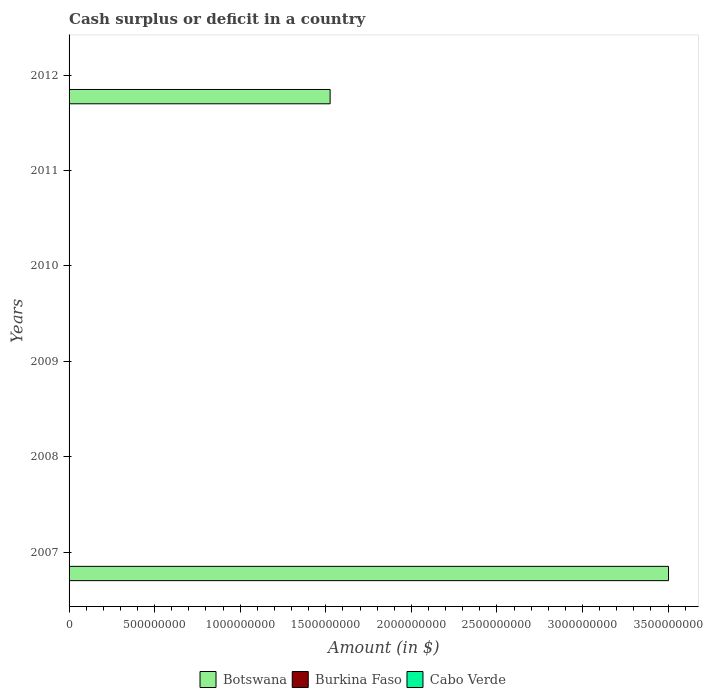How many different coloured bars are there?
Make the answer very short. 1. Are the number of bars on each tick of the Y-axis equal?
Offer a terse response. No. How many bars are there on the 4th tick from the top?
Your response must be concise. 0. Across all years, what is the maximum amount of cash surplus or deficit in Botswana?
Ensure brevity in your answer.  3.50e+09. In which year was the amount of cash surplus or deficit in Botswana maximum?
Your answer should be very brief. 2007. What is the total amount of cash surplus or deficit in Botswana in the graph?
Your answer should be compact. 5.03e+09. What is the difference between the amount of cash surplus or deficit in Cabo Verde in 2008 and the amount of cash surplus or deficit in Burkina Faso in 2007?
Your answer should be compact. 0. What is the average amount of cash surplus or deficit in Cabo Verde per year?
Provide a succinct answer. 0. In how many years, is the amount of cash surplus or deficit in Burkina Faso greater than 3000000000 $?
Provide a succinct answer. 0. What is the difference between the highest and the lowest amount of cash surplus or deficit in Botswana?
Offer a very short reply. 3.50e+09. In how many years, is the amount of cash surplus or deficit in Botswana greater than the average amount of cash surplus or deficit in Botswana taken over all years?
Give a very brief answer. 2. Is it the case that in every year, the sum of the amount of cash surplus or deficit in Botswana and amount of cash surplus or deficit in Cabo Verde is greater than the amount of cash surplus or deficit in Burkina Faso?
Your answer should be very brief. No. Are all the bars in the graph horizontal?
Provide a succinct answer. Yes. Are the values on the major ticks of X-axis written in scientific E-notation?
Offer a terse response. No. What is the title of the graph?
Offer a very short reply. Cash surplus or deficit in a country. What is the label or title of the X-axis?
Offer a very short reply. Amount (in $). What is the label or title of the Y-axis?
Offer a terse response. Years. What is the Amount (in $) in Botswana in 2007?
Your answer should be compact. 3.50e+09. What is the Amount (in $) of Burkina Faso in 2007?
Your response must be concise. 0. What is the Amount (in $) in Cabo Verde in 2007?
Offer a terse response. 0. What is the Amount (in $) in Botswana in 2008?
Provide a short and direct response. 0. What is the Amount (in $) of Botswana in 2009?
Your answer should be compact. 0. What is the Amount (in $) of Burkina Faso in 2009?
Offer a very short reply. 0. What is the Amount (in $) of Cabo Verde in 2009?
Give a very brief answer. 0. What is the Amount (in $) of Cabo Verde in 2010?
Offer a terse response. 0. What is the Amount (in $) of Botswana in 2011?
Keep it short and to the point. 0. What is the Amount (in $) in Burkina Faso in 2011?
Provide a succinct answer. 0. What is the Amount (in $) of Botswana in 2012?
Provide a short and direct response. 1.53e+09. What is the Amount (in $) in Burkina Faso in 2012?
Your answer should be compact. 0. Across all years, what is the maximum Amount (in $) in Botswana?
Your answer should be compact. 3.50e+09. Across all years, what is the minimum Amount (in $) of Botswana?
Your answer should be very brief. 0. What is the total Amount (in $) of Botswana in the graph?
Provide a short and direct response. 5.03e+09. What is the total Amount (in $) in Cabo Verde in the graph?
Keep it short and to the point. 0. What is the difference between the Amount (in $) in Botswana in 2007 and that in 2012?
Give a very brief answer. 1.98e+09. What is the average Amount (in $) of Botswana per year?
Your answer should be compact. 8.38e+08. What is the average Amount (in $) in Cabo Verde per year?
Your answer should be very brief. 0. What is the ratio of the Amount (in $) in Botswana in 2007 to that in 2012?
Offer a very short reply. 2.3. What is the difference between the highest and the lowest Amount (in $) in Botswana?
Your answer should be compact. 3.50e+09. 